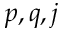<formula> <loc_0><loc_0><loc_500><loc_500>p , q , j</formula> 